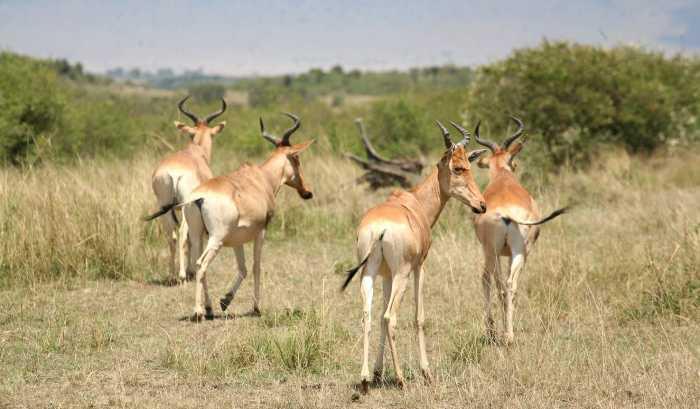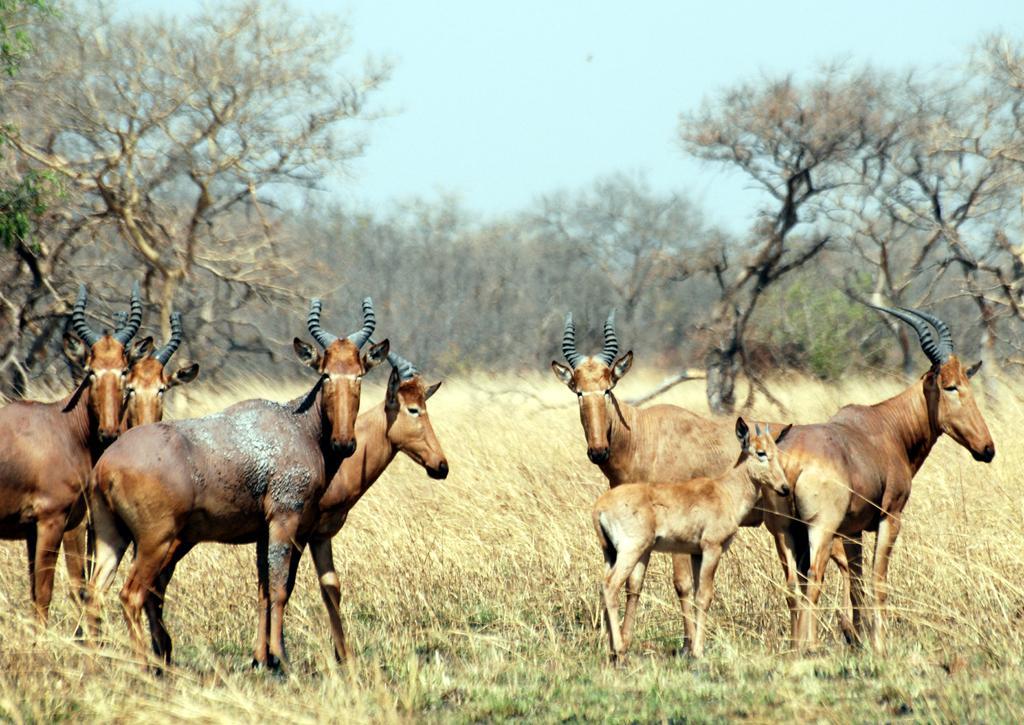The first image is the image on the left, the second image is the image on the right. For the images shown, is this caption "One of the images has exactly two animals in it." true? Answer yes or no. No. 